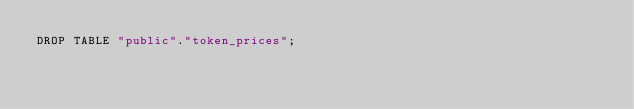Convert code to text. <code><loc_0><loc_0><loc_500><loc_500><_SQL_>DROP TABLE "public"."token_prices";
</code> 